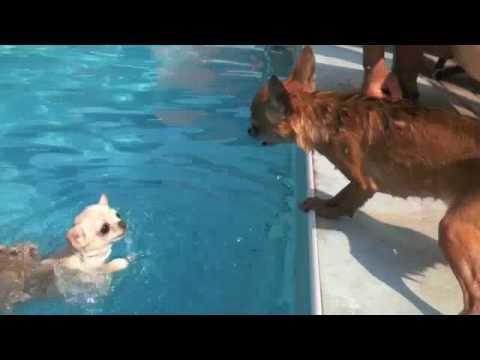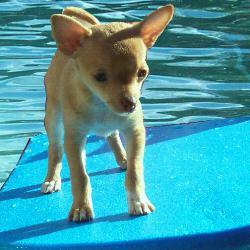The first image is the image on the left, the second image is the image on the right. For the images displayed, is the sentence "A single dog is standing up inside a kiddie pool, in one image." factually correct? Answer yes or no. No. The first image is the image on the left, the second image is the image on the right. Assess this claim about the two images: "In one image, a small dog is standing in a kids' plastic pool, while the second image shows a similar dog in a large inground swimming pool, either in or near a floatation device.". Correct or not? Answer yes or no. No. 